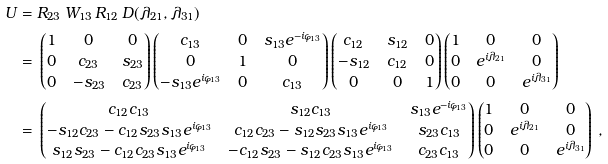<formula> <loc_0><loc_0><loc_500><loc_500>U = \null & \null R _ { 2 3 } \, W _ { 1 3 } \, R _ { 1 2 } \, D ( \lambda _ { 2 1 } , \lambda _ { 3 1 } ) \\ = \null & \null \begin{pmatrix} 1 & 0 & 0 \\ 0 & c _ { 2 3 } & s _ { 2 3 } \\ 0 & - s _ { 2 3 } & c _ { 2 3 } \end{pmatrix} \begin{pmatrix} c _ { 1 3 } & 0 & s _ { 1 3 } e ^ { - i \varphi _ { 1 3 } } \\ 0 & 1 & 0 \\ - s _ { 1 3 } e ^ { i \varphi _ { 1 3 } } & 0 & c _ { 1 3 } \end{pmatrix} \begin{pmatrix} c _ { 1 2 } & s _ { 1 2 } & 0 \\ - s _ { 1 2 } & c _ { 1 2 } & 0 \\ 0 & 0 & 1 \end{pmatrix} \begin{pmatrix} 1 & 0 & 0 \\ 0 & e ^ { i \lambda _ { 2 1 } } & 0 \\ 0 & 0 & e ^ { i \lambda _ { 3 1 } } \end{pmatrix} \\ = \null & \null \begin{pmatrix} c _ { 1 2 } c _ { 1 3 } & s _ { 1 2 } c _ { 1 3 } & s _ { 1 3 } e ^ { - i \varphi _ { 1 3 } } \\ - s _ { 1 2 } c _ { 2 3 } - c _ { 1 2 } s _ { 2 3 } s _ { 1 3 } e ^ { i \varphi _ { 1 3 } } & c _ { 1 2 } c _ { 2 3 } - s _ { 1 2 } s _ { 2 3 } s _ { 1 3 } e ^ { i \varphi _ { 1 3 } } & s _ { 2 3 } c _ { 1 3 } \\ s _ { 1 2 } s _ { 2 3 } - c _ { 1 2 } c _ { 2 3 } s _ { 1 3 } e ^ { i \varphi _ { 1 3 } } & - c _ { 1 2 } s _ { 2 3 } - s _ { 1 2 } c _ { 2 3 } s _ { 1 3 } e ^ { i \varphi _ { 1 3 } } & c _ { 2 3 } c _ { 1 3 } \end{pmatrix} \begin{pmatrix} 1 & 0 & 0 \\ 0 & e ^ { i \lambda _ { 2 1 } } & 0 \\ 0 & 0 & e ^ { i \lambda _ { 3 1 } } \end{pmatrix} \, ,</formula> 